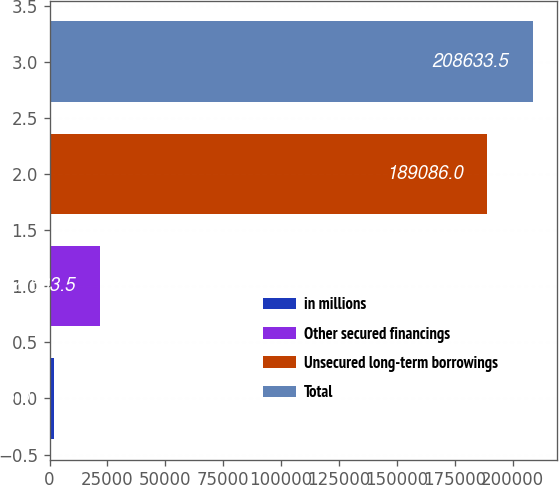<chart> <loc_0><loc_0><loc_500><loc_500><bar_chart><fcel>in millions<fcel>Other secured financings<fcel>Unsecured long-term borrowings<fcel>Total<nl><fcel>2016<fcel>21563.5<fcel>189086<fcel>208634<nl></chart> 